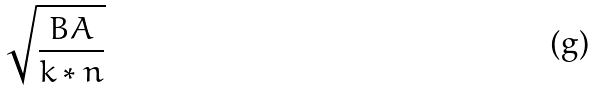Convert formula to latex. <formula><loc_0><loc_0><loc_500><loc_500>\sqrt { \frac { B A } { k * n } }</formula> 